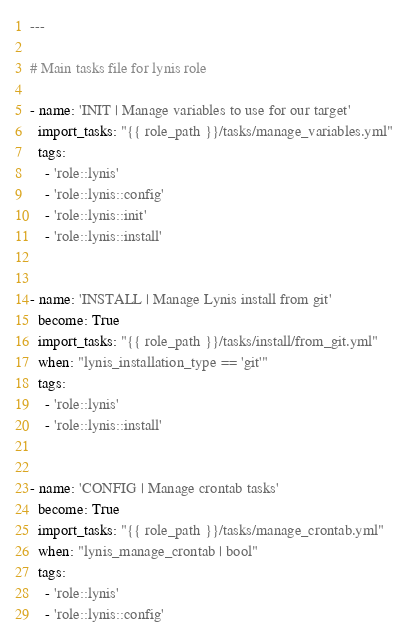<code> <loc_0><loc_0><loc_500><loc_500><_YAML_>---

# Main tasks file for lynis role

- name: 'INIT | Manage variables to use for our target'
  import_tasks: "{{ role_path }}/tasks/manage_variables.yml"
  tags:
    - 'role::lynis'
    - 'role::lynis::config'
    - 'role::lynis::init'
    - 'role::lynis::install'


- name: 'INSTALL | Manage Lynis install from git'
  become: True
  import_tasks: "{{ role_path }}/tasks/install/from_git.yml"
  when: "lynis_installation_type == 'git'"
  tags:
    - 'role::lynis'
    - 'role::lynis::install'


- name: 'CONFIG | Manage crontab tasks'
  become: True
  import_tasks: "{{ role_path }}/tasks/manage_crontab.yml"
  when: "lynis_manage_crontab | bool"
  tags:
    - 'role::lynis'
    - 'role::lynis::config'
</code> 